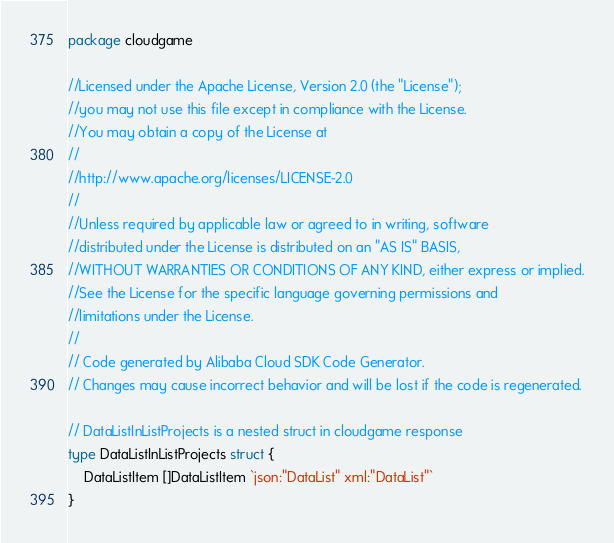Convert code to text. <code><loc_0><loc_0><loc_500><loc_500><_Go_>package cloudgame

//Licensed under the Apache License, Version 2.0 (the "License");
//you may not use this file except in compliance with the License.
//You may obtain a copy of the License at
//
//http://www.apache.org/licenses/LICENSE-2.0
//
//Unless required by applicable law or agreed to in writing, software
//distributed under the License is distributed on an "AS IS" BASIS,
//WITHOUT WARRANTIES OR CONDITIONS OF ANY KIND, either express or implied.
//See the License for the specific language governing permissions and
//limitations under the License.
//
// Code generated by Alibaba Cloud SDK Code Generator.
// Changes may cause incorrect behavior and will be lost if the code is regenerated.

// DataListInListProjects is a nested struct in cloudgame response
type DataListInListProjects struct {
	DataListItem []DataListItem `json:"DataList" xml:"DataList"`
}
</code> 